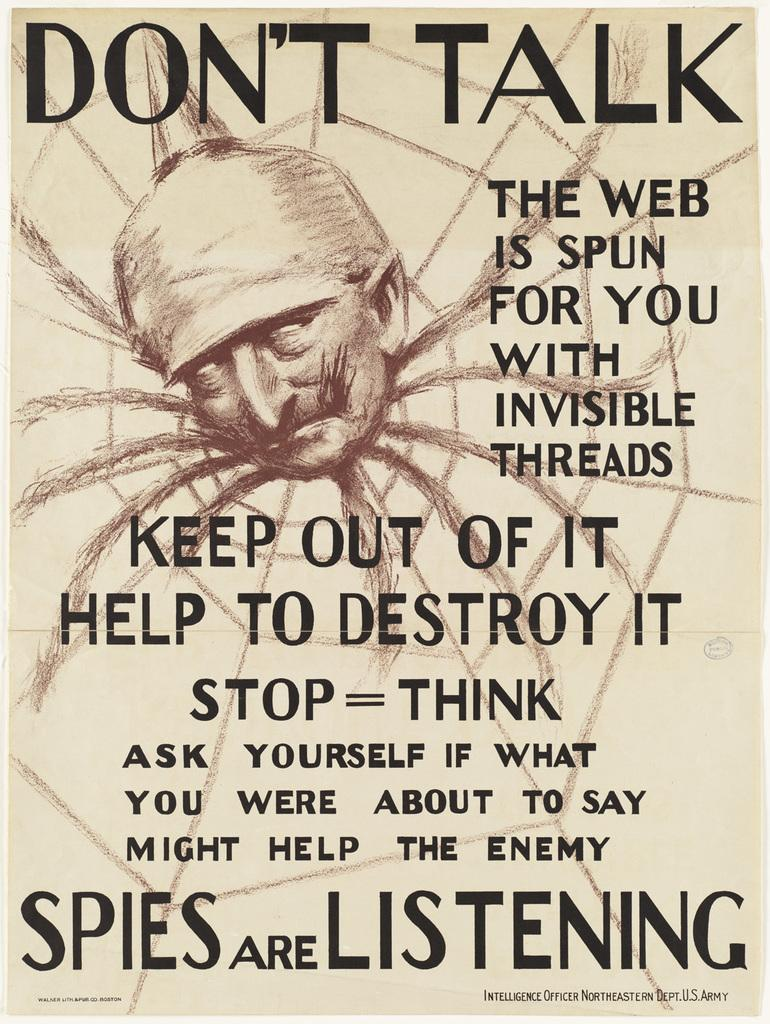What is the main subject of the image? There is a person's face in the image. What else can be seen in the image besides the person's face? There is a web and text written on the image. What type of sweater is the person wearing in the image? There is no sweater visible in the image; only the person's face, a web, and text are present. Can you describe the clouds in the image? There are no clouds present in the image. 